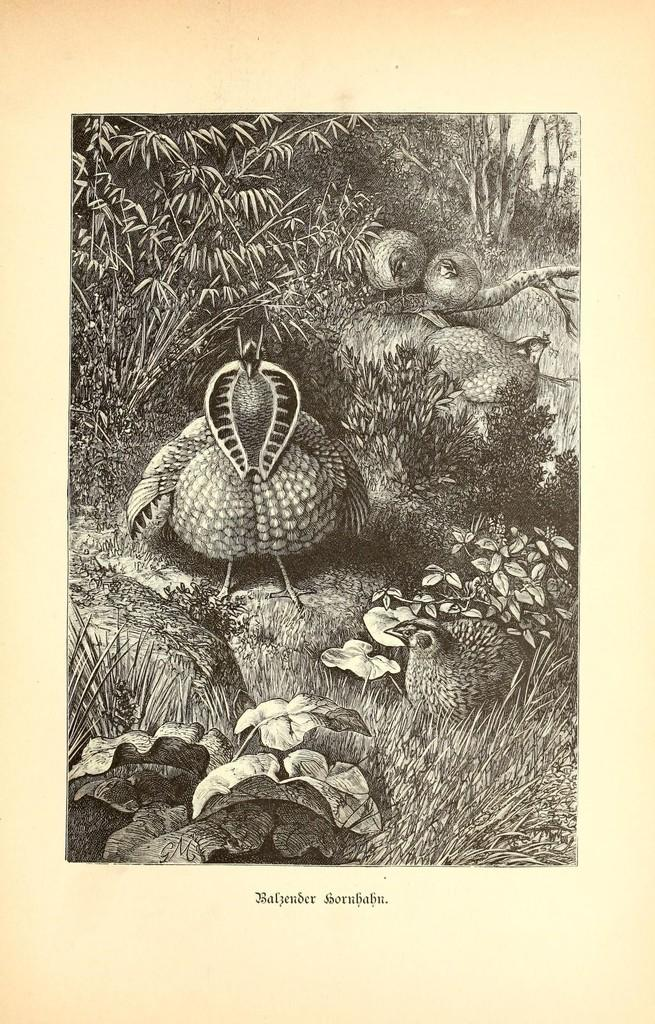What is the main object in the image? The image contains a paper. What can be found on the paper? There are words, a photo of animals, a photo of plants, and a photo of trees on the paper. Can you describe the content of the photos on the paper? The paper contains photos of animals, plants, and trees. What type of butter can be seen melting on the paper in the image? There is no butter present in the image; it contains a paper with words and photos of animals, plants, and trees. 